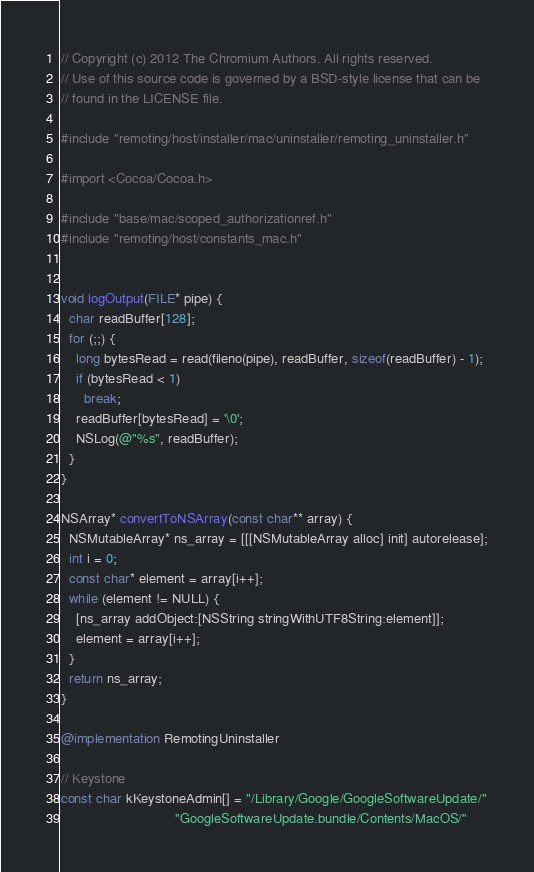<code> <loc_0><loc_0><loc_500><loc_500><_ObjectiveC_>// Copyright (c) 2012 The Chromium Authors. All rights reserved.
// Use of this source code is governed by a BSD-style license that can be
// found in the LICENSE file.

#include "remoting/host/installer/mac/uninstaller/remoting_uninstaller.h"

#import <Cocoa/Cocoa.h>

#include "base/mac/scoped_authorizationref.h"
#include "remoting/host/constants_mac.h"


void logOutput(FILE* pipe) {
  char readBuffer[128];
  for (;;) {
    long bytesRead = read(fileno(pipe), readBuffer, sizeof(readBuffer) - 1);
    if (bytesRead < 1)
      break;
    readBuffer[bytesRead] = '\0';
    NSLog(@"%s", readBuffer);
  }
}

NSArray* convertToNSArray(const char** array) {
  NSMutableArray* ns_array = [[[NSMutableArray alloc] init] autorelease];
  int i = 0;
  const char* element = array[i++];
  while (element != NULL) {
    [ns_array addObject:[NSString stringWithUTF8String:element]];
    element = array[i++];
  }
  return ns_array;
}

@implementation RemotingUninstaller

// Keystone
const char kKeystoneAdmin[] = "/Library/Google/GoogleSoftwareUpdate/"
                              "GoogleSoftwareUpdate.bundle/Contents/MacOS/"</code> 